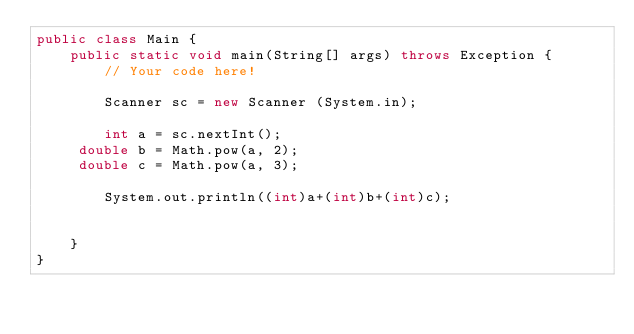<code> <loc_0><loc_0><loc_500><loc_500><_Java_>public class Main {
    public static void main(String[] args) throws Exception {
        // Your code here!

        Scanner sc = new Scanner (System.in);
        
        int a = sc.nextInt();
     double b = Math.pow(a, 2);
     double c = Math.pow(a, 3);
    
        System.out.println((int)a+(int)b+(int)c);
    
    
    }
}</code> 